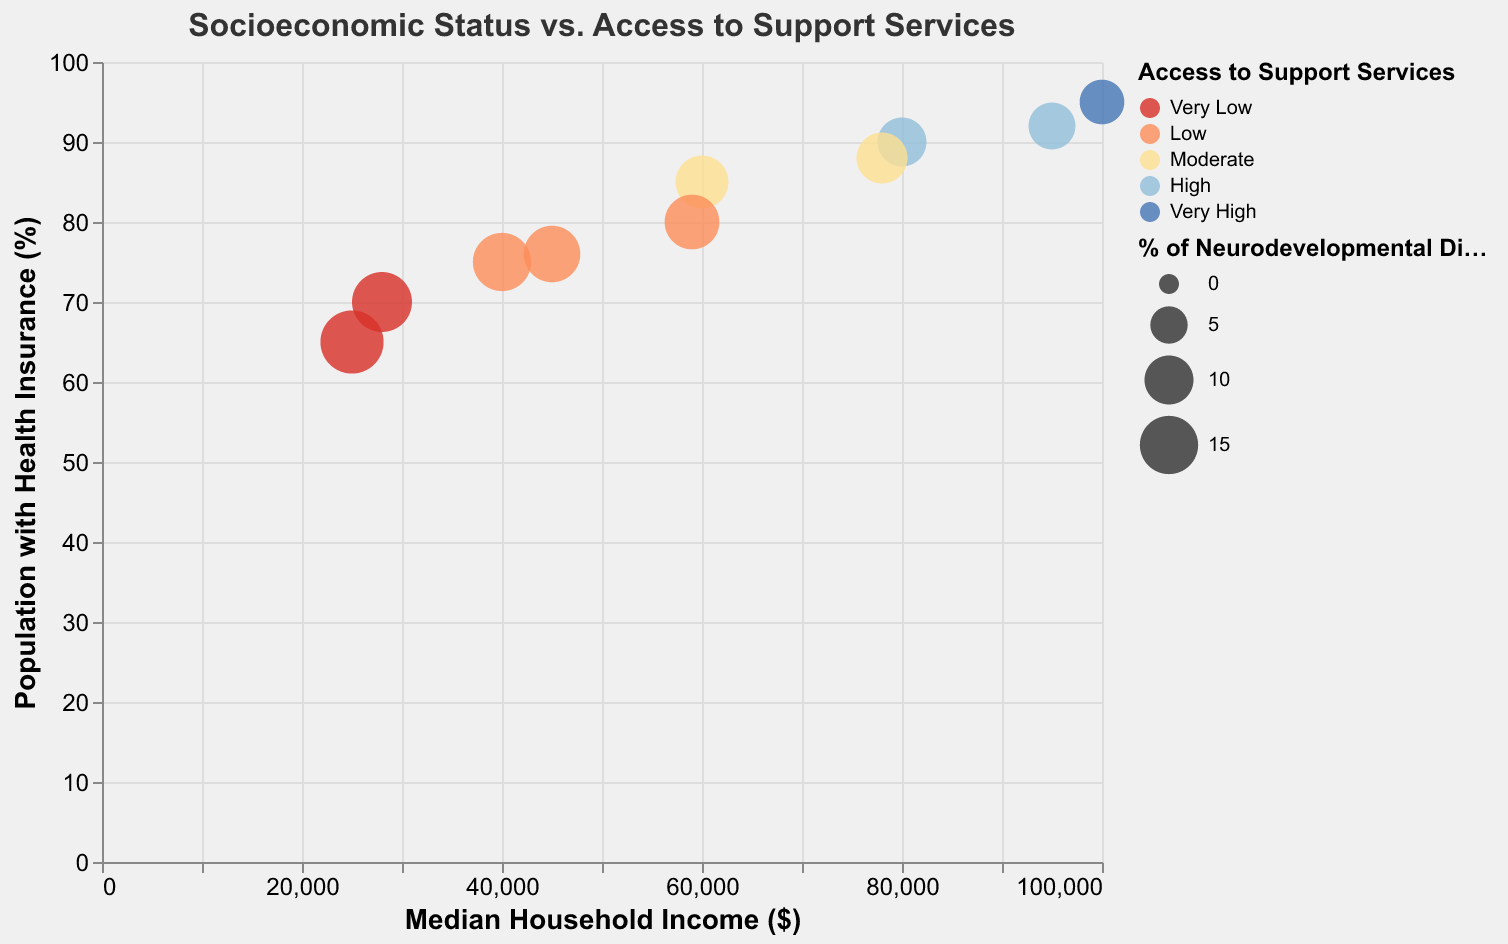What's the title of the chart? The title of the chart is located at the top and reads "Socioeconomic Status vs. Access to Support Services". This summarizes what the x and y-axes plot.
Answer: Socioeconomic Status vs. Access to Support Services What does the size of the bubbles represent? According to the legend, the size of the bubbles represents the "Percentage of Neurodevelopmental Disorders". Larger bubbles correspond to higher percentages.
Answer: Percentage of Neurodevelopmental Disorders Which socioeconomic status group has the highest access to support services? By looking at the color of the bubbles in the chart, the "High" socioeconomic status has the highest access, marked by the "Very High" color.
Answer: High Which socioeconomic status group has the lowest median household income? The bubble positioned furthest to the left on the x-axis represents the "Low" socioeconomic status group with the lowest median household income of $25,000.
Answer: Low What is the relationship between median household income and the percentage of the population with health insurance? Observing the x (Median Household Income) and y (% of Population with Health Insurance) axes, there is a positive correlation: as median household income increases, the percentage of the population with health insurance also tends to increase.
Answer: Positive correlation Which group has the highest percentage of neurodevelopmental disorders and what is the access to support services for this group? The largest bubble represents this group, and it is the "Low" socioeconomic status group with 18% of neurodevelopmental disorders and "Very Low" access to support services, indicated by the darkest red color.
Answer: Low, Very Low Compare the percentage of the population with health insurance for "Medium High" and "Medium Low" socioeconomic statuses. Which has a higher percentage? Referring to the y-axis, the "Medium High" group has 88% with health insurance, while the "Medium Low" group has 76%. Therefore, the "Medium High" group has a higher percentage.
Answer: Medium High Estimate the median household income and percentage of the population with health insurance for the "Medium" socioeconomic status with low access to support services. The "Medium" socioeconomic status with "Low" access to support services has a median household income of approximately $59,000 and about 80% of the population with health insurance.
Answer: $59,000 and 80% How many socio-economic classifications are found in the dataset used in the chart? By observing the legend and counting the distinct categories, we find five socio-economic classifications: High, Medium High, Medium, Medium Low, and Low.
Answer: Five 